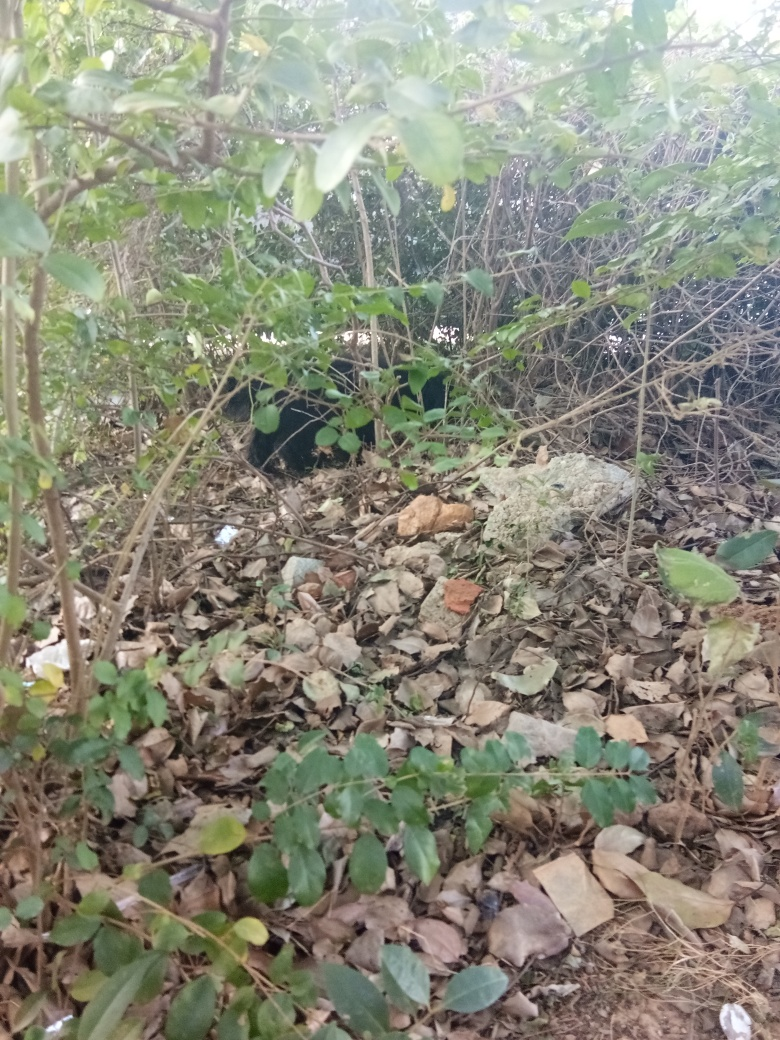Does this environment look like it is well cared for or neglected? The environment in the image appears somewhat neglected. There are signs of scattered debris and litter, and the vegetation looks overgrown and uncultivated. It seems like the area could benefit from some cleaning up and maintenance. 